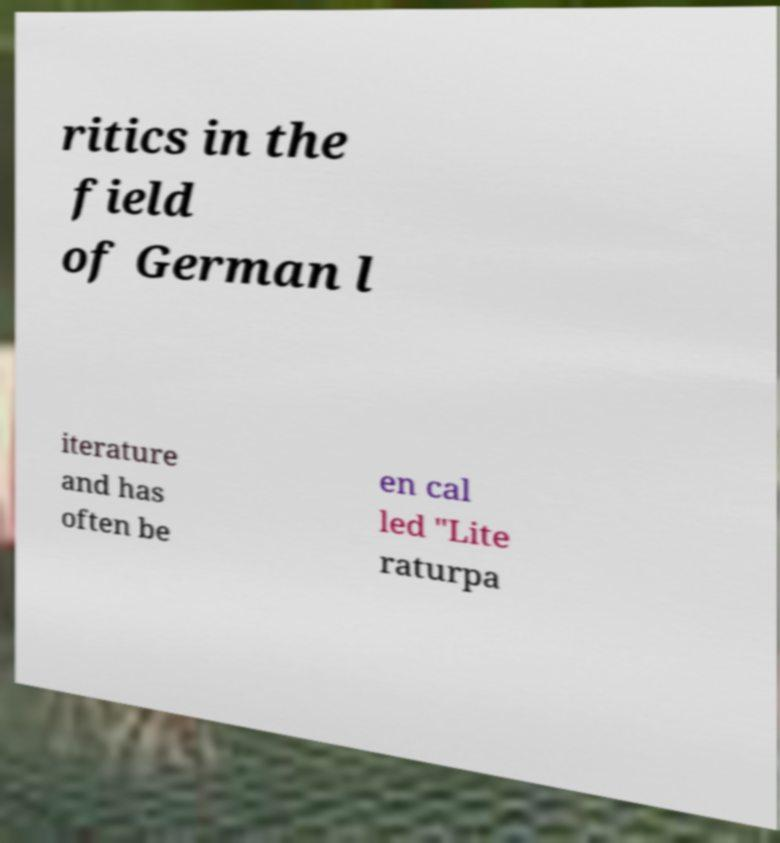Could you extract and type out the text from this image? ritics in the field of German l iterature and has often be en cal led "Lite raturpa 